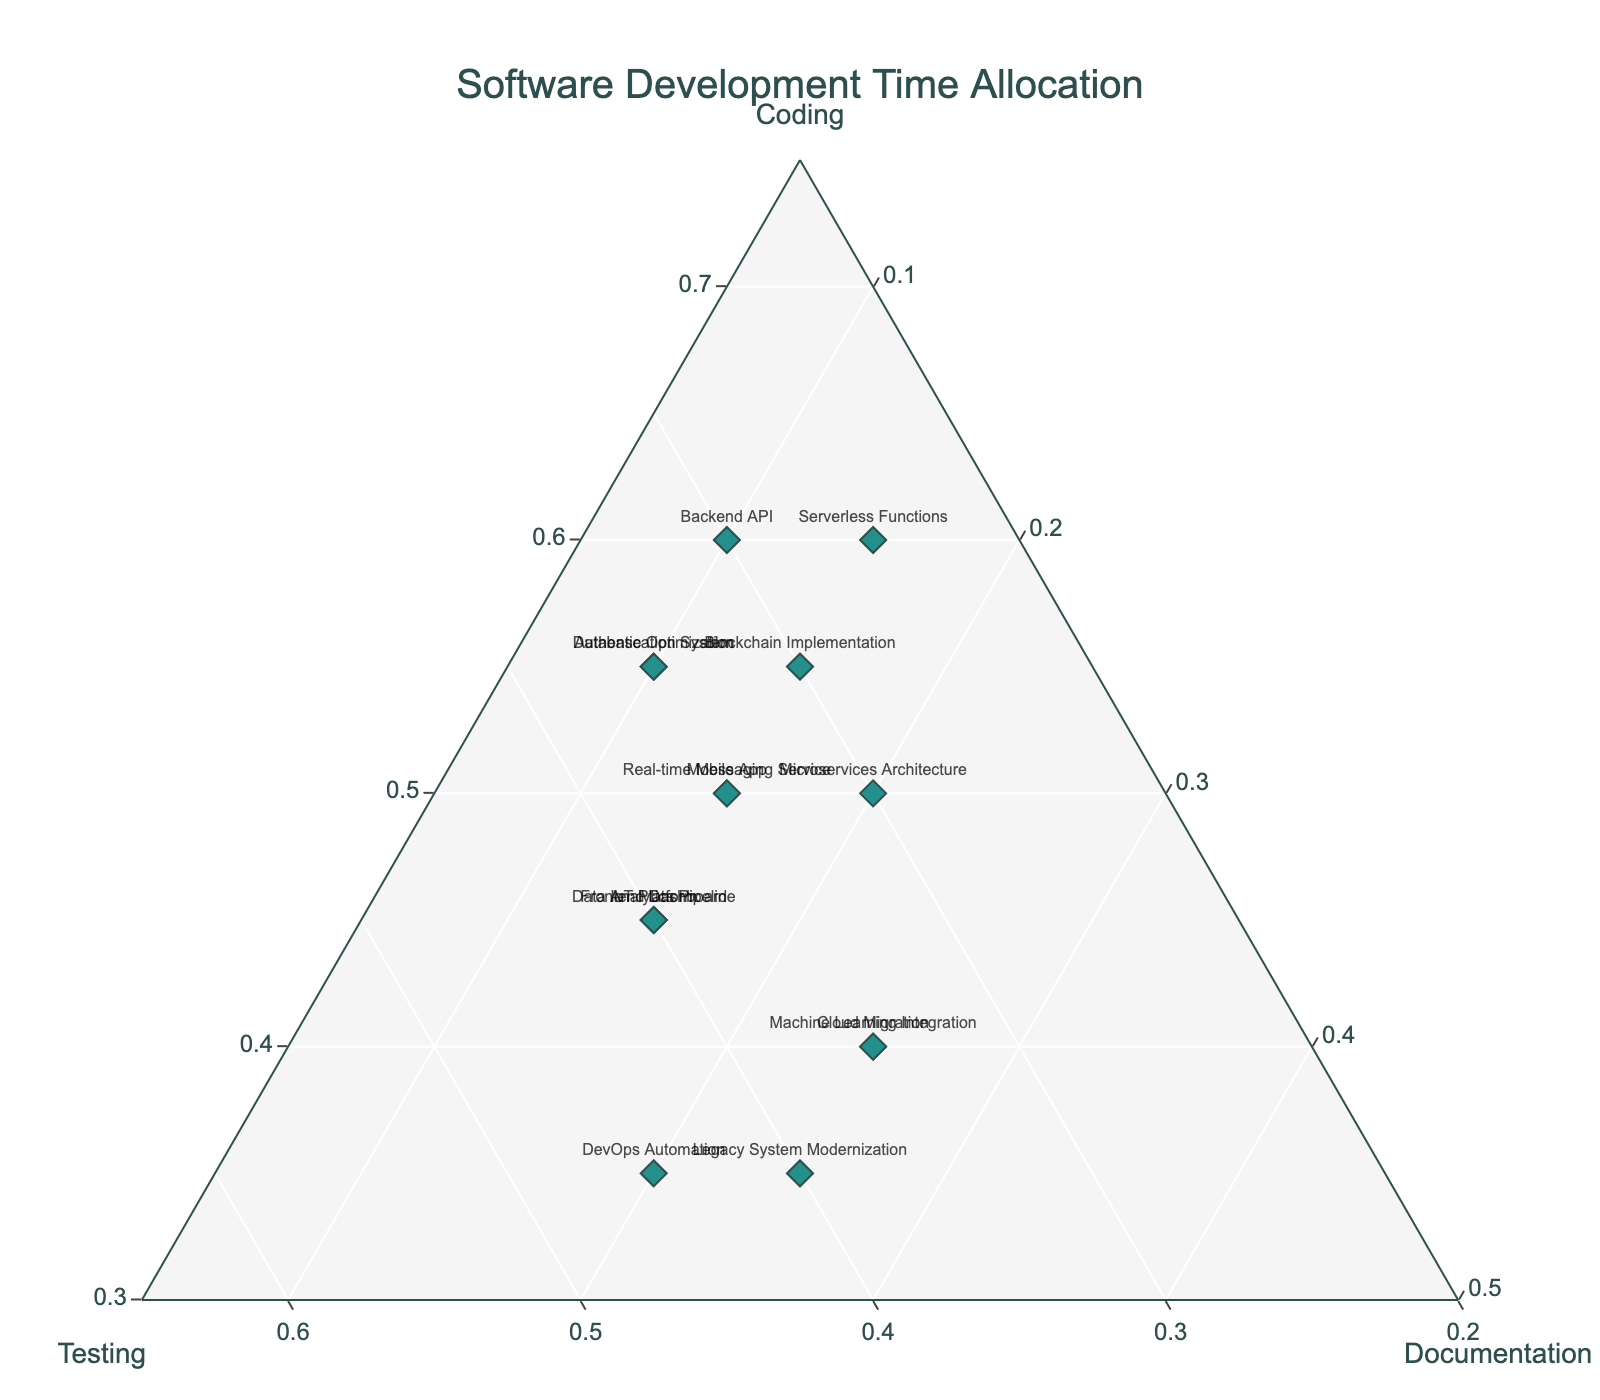What is the title of the figure? The title is displayed at the top center of the plot, which is a common location for the title of a figure. Observing the title area reveals the text that represents the title of the figure.
Answer: Software Development Time Allocation How many projects allocate 25% or more of their time to documentation? To answer this, look at the points near the 'Documentation' axis on the ternary plot. Count the number of points where the fraction of documentation is 0.25 or more. These points will be closer to the 'Documentation' axis.
Answer: 4 Which project allocates the highest percentage of its time to coding? Locate the point that is closest to the 'Coding' axis. The distance from the axis determines the proportion of time spent on coding. The project label associated with this point indicates the project that spends the most time on coding.
Answer: Backend API and Serverless Functions Which project has the most balanced time allocation among coding, testing, and documentation? Identify the point closest to the center of the plot since a balanced allocation means approximate equality in all three aspects. The project associated with this central point represents the most balanced allocation.
Answer: Microservices Architecture Among the projects that allocate at least 30% of their time to testing, which project allocates the least time to coding? First, identify all points representing projects with at least 30% testing (closer to the 'Testing' axis). Among these points, find the one that is farthest from the 'Coding' axis. The corresponding label reveals the project with the least coding time.
Answer: DevOps Automation How many projects allocate more time to testing than to coding? Compare the number of points closer to the 'Testing' axis than the 'Coding' axis. Count these points, noting which projects they represent. This can be visually determined by their relative positions on the plot.
Answer: 2 What is the average percentage of time allocated to documentation across all projects? For each project, look at the percentage of time spent on documentation. Add these percentages together and divide by the number of projects to obtain the average. Detailed data values from the plot show: \((10 + 15 + 10 + 15 + 25 + 10 + 15 + 20 + 20 + 25 + 15 + 15 + 15 + 25 + 15) / 15 = 16.67\)
Answer: 16.67% Which two projects have the closest time allocation proportions for coding and documentation? Examine points that are closest to each other in terms of their 'Coding' and 'Documentation' proportions. Assess visually or compare proportions to identify the two nearest points.
Answer: Database Optimization and Authentication System How does the time allocated to documentation in the Cloud Migration project compare to that in the Machine Learning Integration project? Identify the positions representing these two projects on the plot and compare their distances from the 'Documentation' axis. The closer point indicates more time allocated to documentation.
Answer: They are equal 